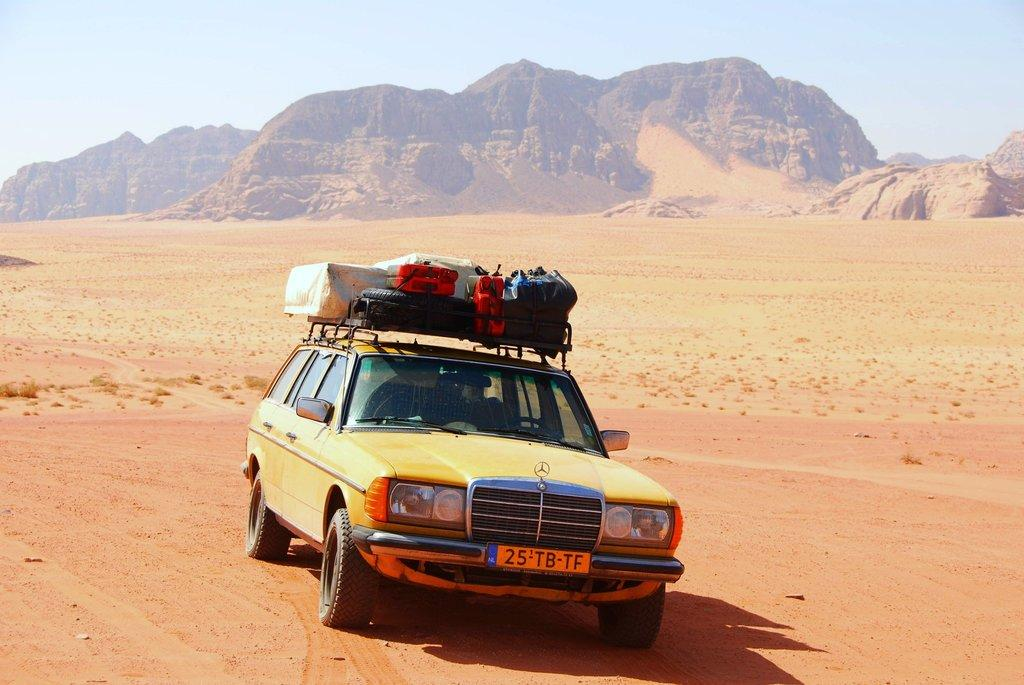What is the main subject in the middle of the image? There is a car in the middle of the image. What is placed on top of the car? There is luggage on top of the car. What type of terrain can be seen in the background of the image? There is sand visible in the background of the image, and there are hills as well. What part of the natural environment is visible in the background of the image? The sky is visible in the background of the image. What type of doctor is standing near the car in the image? There is no doctor present in the image; it only features a car with luggage on top of it. 